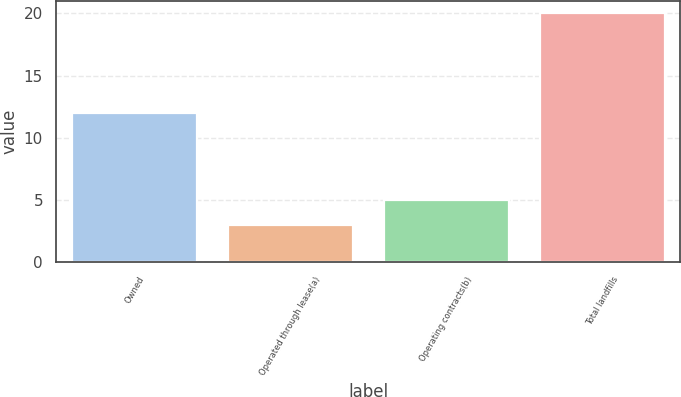Convert chart. <chart><loc_0><loc_0><loc_500><loc_500><bar_chart><fcel>Owned<fcel>Operated through lease(a)<fcel>Operating contracts(b)<fcel>Total landfills<nl><fcel>12<fcel>3<fcel>5<fcel>20<nl></chart> 